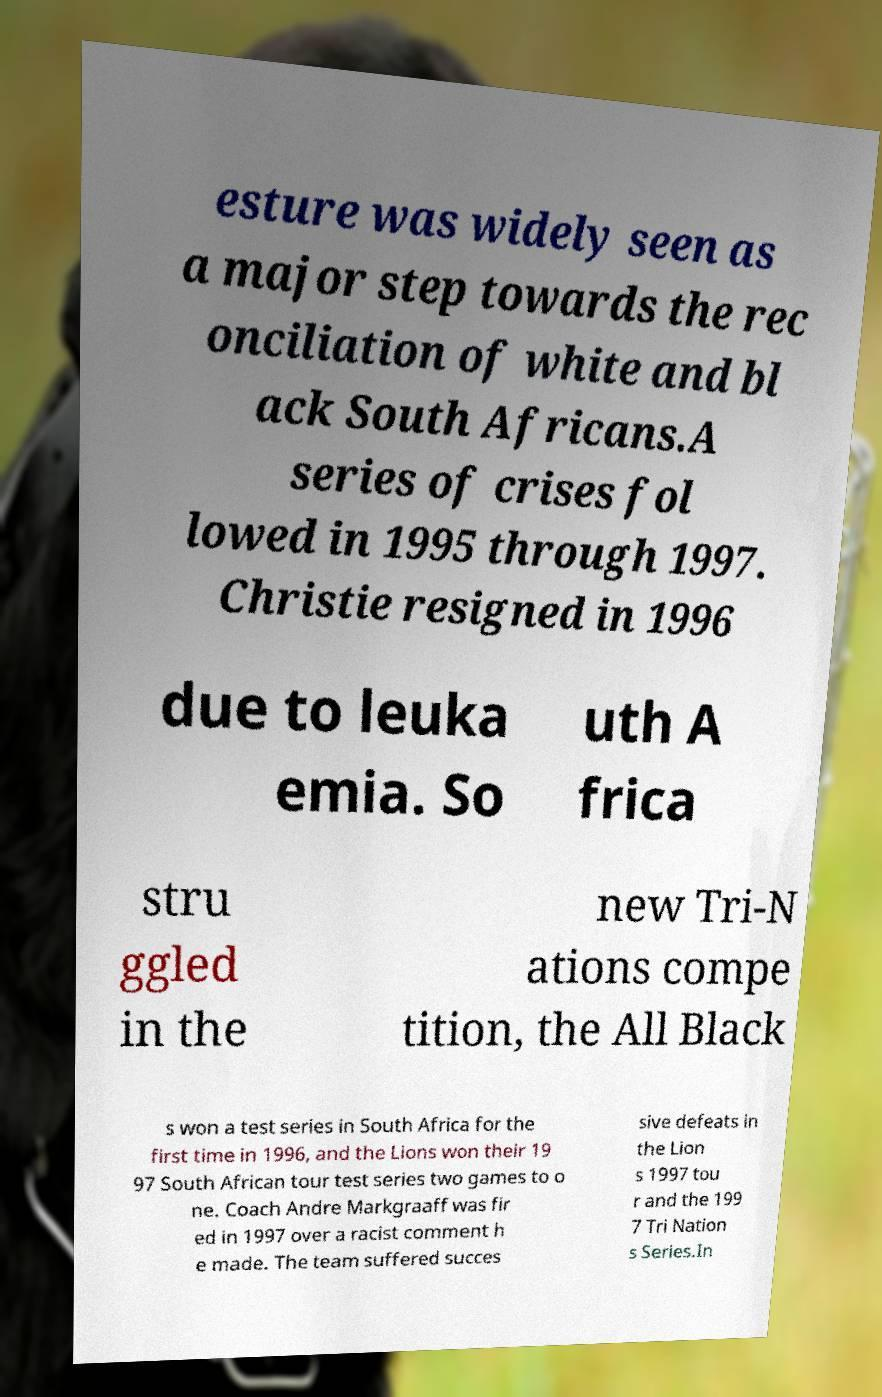I need the written content from this picture converted into text. Can you do that? esture was widely seen as a major step towards the rec onciliation of white and bl ack South Africans.A series of crises fol lowed in 1995 through 1997. Christie resigned in 1996 due to leuka emia. So uth A frica stru ggled in the new Tri-N ations compe tition, the All Black s won a test series in South Africa for the first time in 1996, and the Lions won their 19 97 South African tour test series two games to o ne. Coach Andre Markgraaff was fir ed in 1997 over a racist comment h e made. The team suffered succes sive defeats in the Lion s 1997 tou r and the 199 7 Tri Nation s Series.In 